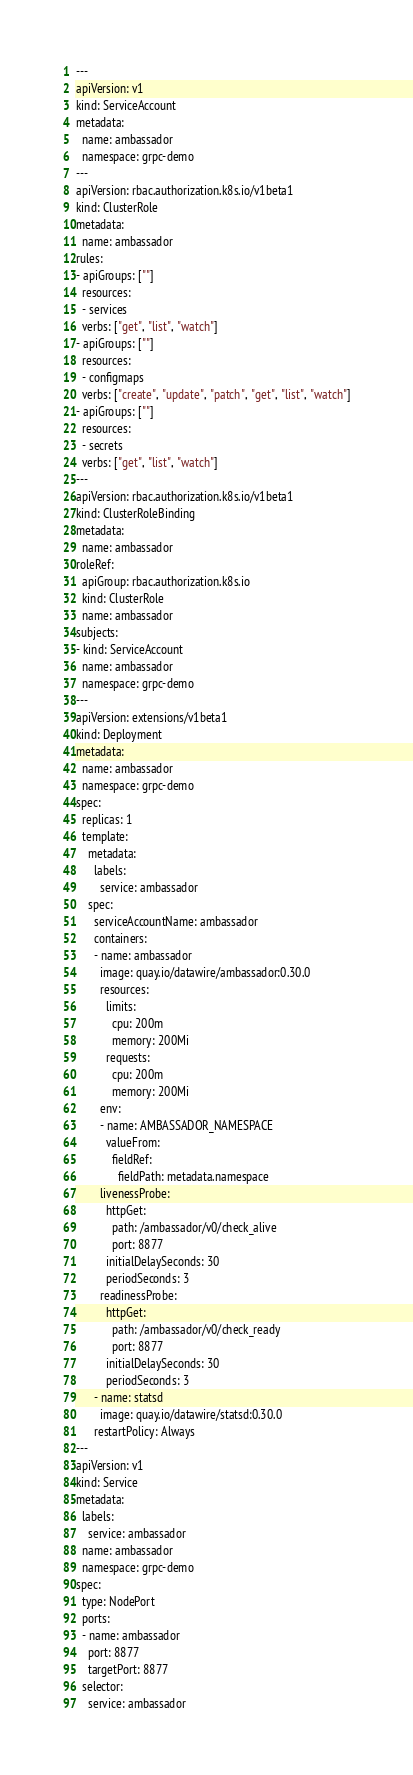Convert code to text. <code><loc_0><loc_0><loc_500><loc_500><_YAML_>---
apiVersion: v1
kind: ServiceAccount
metadata:
  name: ambassador
  namespace: grpc-demo
---
apiVersion: rbac.authorization.k8s.io/v1beta1
kind: ClusterRole
metadata:
  name: ambassador
rules:
- apiGroups: [""]
  resources:
  - services
  verbs: ["get", "list", "watch"]
- apiGroups: [""]
  resources:
  - configmaps
  verbs: ["create", "update", "patch", "get", "list", "watch"]
- apiGroups: [""]
  resources:
  - secrets
  verbs: ["get", "list", "watch"]
---
apiVersion: rbac.authorization.k8s.io/v1beta1
kind: ClusterRoleBinding
metadata:
  name: ambassador
roleRef:
  apiGroup: rbac.authorization.k8s.io
  kind: ClusterRole
  name: ambassador
subjects:
- kind: ServiceAccount
  name: ambassador
  namespace: grpc-demo
---
apiVersion: extensions/v1beta1
kind: Deployment
metadata:
  name: ambassador
  namespace: grpc-demo
spec:
  replicas: 1
  template:
    metadata:
      labels:
        service: ambassador
    spec:
      serviceAccountName: ambassador
      containers:
      - name: ambassador
        image: quay.io/datawire/ambassador:0.30.0
        resources:
          limits:
            cpu: 200m
            memory: 200Mi
          requests:
            cpu: 200m
            memory: 200Mi
        env:
        - name: AMBASSADOR_NAMESPACE
          valueFrom:
            fieldRef:
              fieldPath: metadata.namespace          
        livenessProbe:
          httpGet:
            path: /ambassador/v0/check_alive
            port: 8877
          initialDelaySeconds: 30
          periodSeconds: 3
        readinessProbe:
          httpGet:
            path: /ambassador/v0/check_ready
            port: 8877
          initialDelaySeconds: 30
          periodSeconds: 3
      - name: statsd
        image: quay.io/datawire/statsd:0.30.0
      restartPolicy: Always
---
apiVersion: v1
kind: Service
metadata:
  labels:
    service: ambassador
  name: ambassador
  namespace: grpc-demo
spec:
  type: NodePort
  ports:
  - name: ambassador
    port: 8877
    targetPort: 8877
  selector:
    service: ambassador</code> 